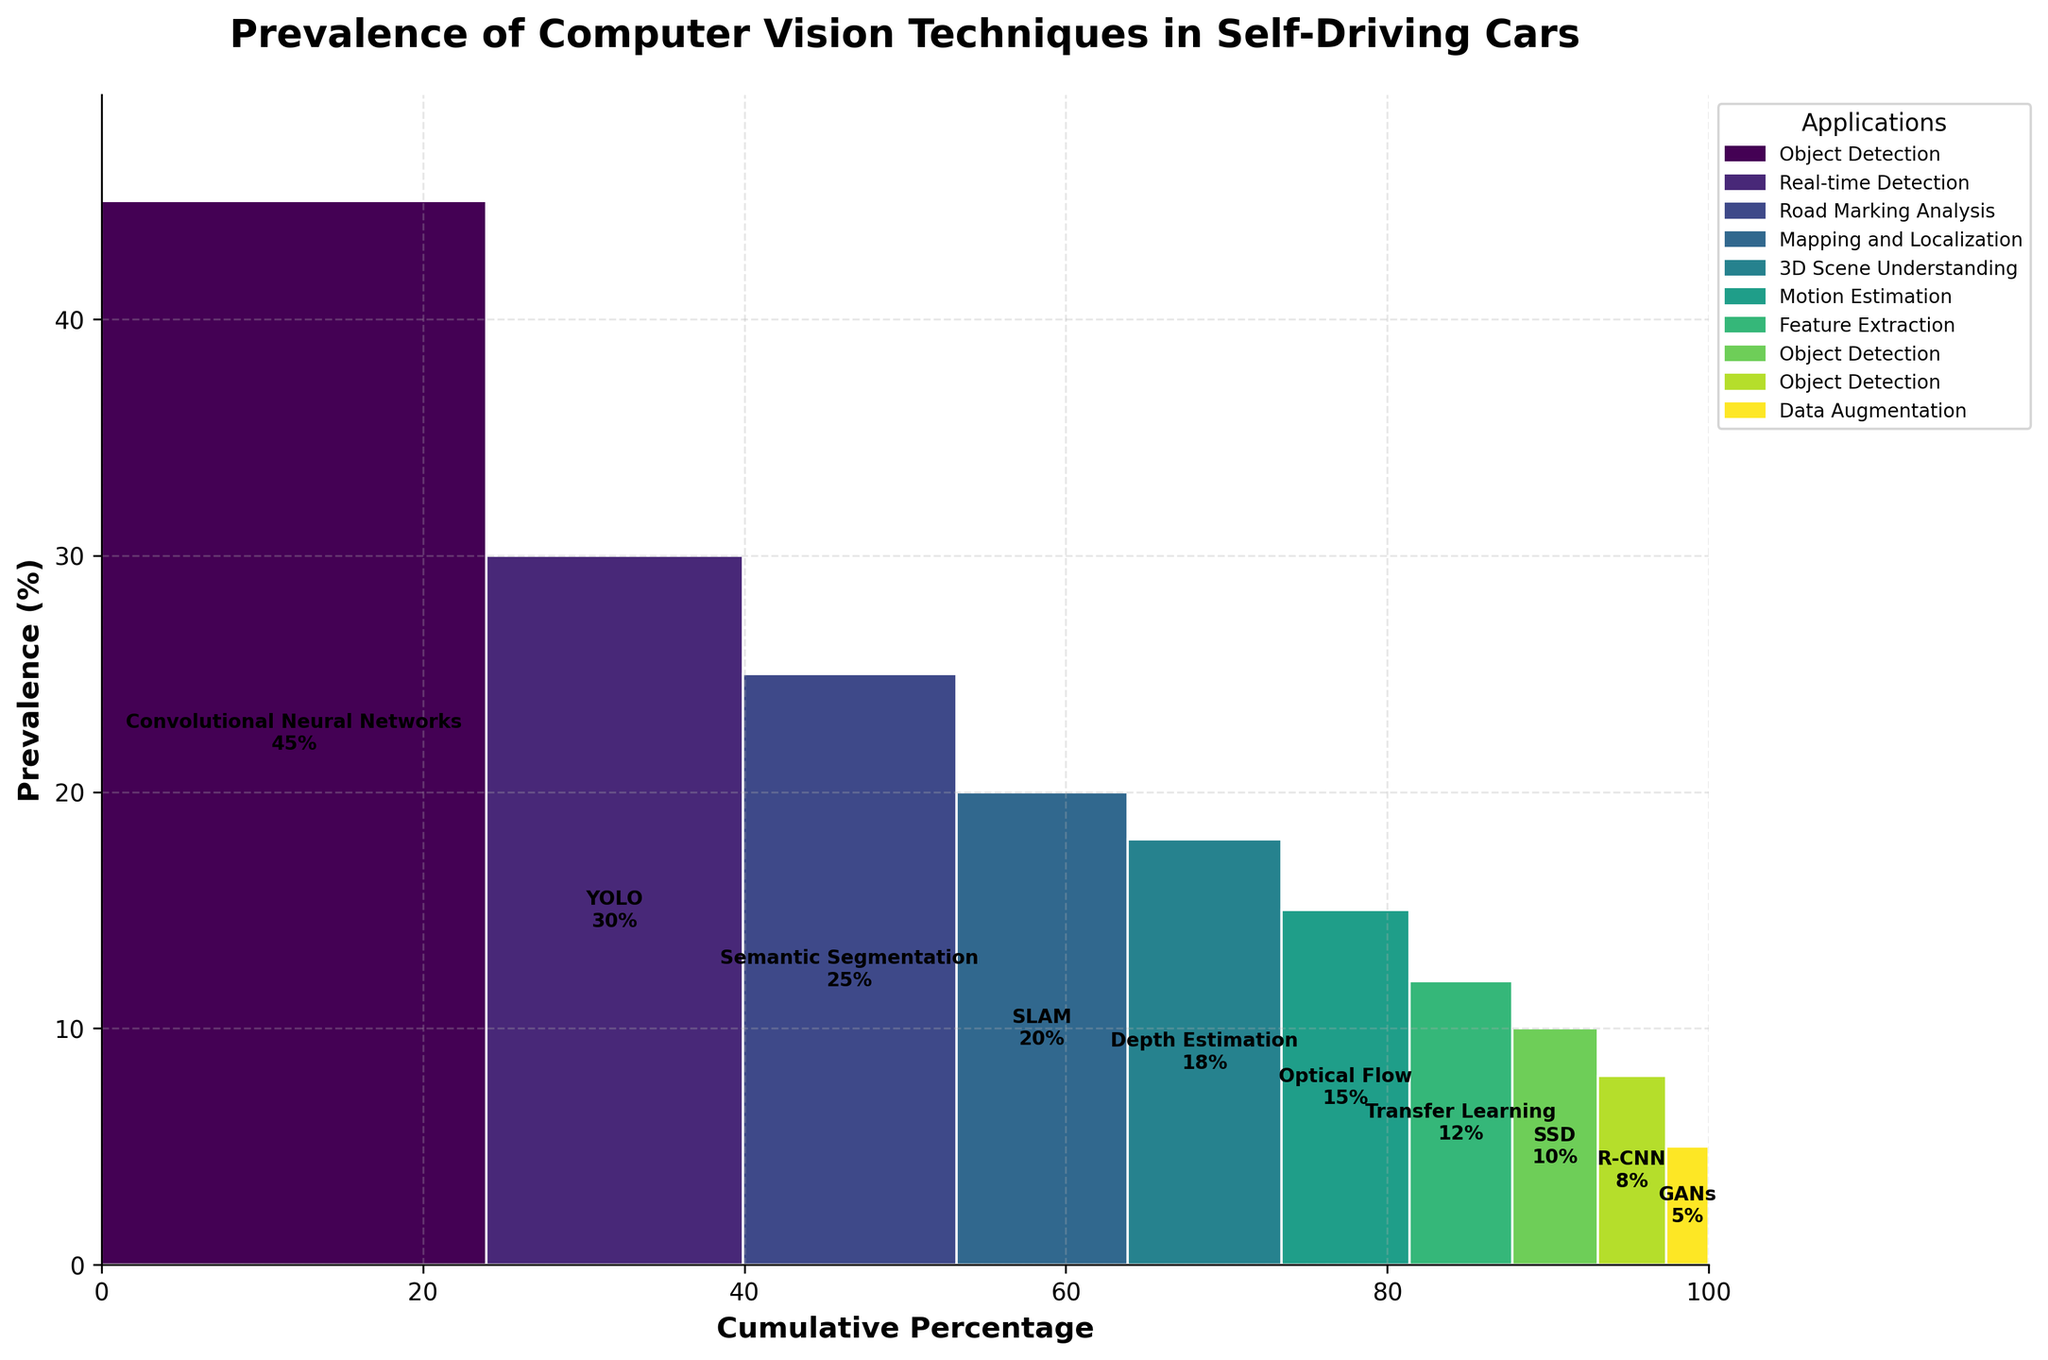What is the title of the figure? The title of the figure is written at the top center of the plot, indicating what the visualization is about.
Answer: Prevalence of Computer Vision Techniques in Self-Driving Cars Which technique has the highest prevalence? The figure lists the techniques in descending order of prevalence, with the highest at the top. The technique at the top with the highest percentage is the one with the highest prevalence.
Answer: Convolutional Neural Networks (45%) How many techniques are used for object detection? To determine the number of techniques used for object detection, identify all the segments in the plot labeled with "Object Detection". There are three such segments: Convolutional Neural Networks, SSD, and R-CNN.
Answer: 3 What is the cumulative percentage at the point where YOLO is added? YOLO is second in the list, and its cumulative percentage will be the sum of the prevalence of the first technique (Convolutional Neural Networks) and YOLO itself. Since Convolutional Neural Networks (45%) plus YOLO (30%) equals 75%, the cumulative percentage for YOLO is 75%.
Answer: 75% Compare the prevalence of Optical Flow and Depth Estimation. Which one is used more frequently? By identifying the segments corresponding to Optical Flow and Depth Estimation, we see that Optical Flow has a prevalence of 15% while Depth Estimation has a prevalence of 18%. So, Depth Estimation is used more frequently.
Answer: Depth Estimation What is the combined prevalence of all techniques that contribute to Mapping and Localization? To find the combined prevalence, locate the segment for SLAM, which is used for Mapping and Localization, and sum its prevalence. Since SLAM is the only technique mentioned for Mapping and Localization at 20%, the combined prevalence is 20%.
Answer: 20% What is the median prevalence value among all techniques? To find the median, list the prevalence values in order: 3, 5, 8, 10, 12, 15, 18, 20, 25, 30, 45. The middle value in this ordered list is the median.
Answer: 15% Which application has the least number of associated techniques? By counting the number of different techniques associated with each application, you determine that Data Augmentation has only one associated technique (GANs), which is fewer than any other application.
Answer: Data Augmentation If you were to add a technique with a prevalence of 22%, where would it fall in the cumulative percentage order? To find its place, we need to see where 22% fits in the cumulative percentage order. The cumulative percentages of 20%+25%=45% and 45%+18%=63%, so 22% would place between SLAM (20%) and Semantic Segmentation (25%), making the cumulative percentage around 67%.
Answer: Between SLAM and Semantic Segmentation Which technique has the lowest prevalence, and what is it? By identifying the segment with the smallest percentage value in the plot, we can determine that the technique with the lowest prevalence is GANs at 5%.
Answer: GANs (5%) 